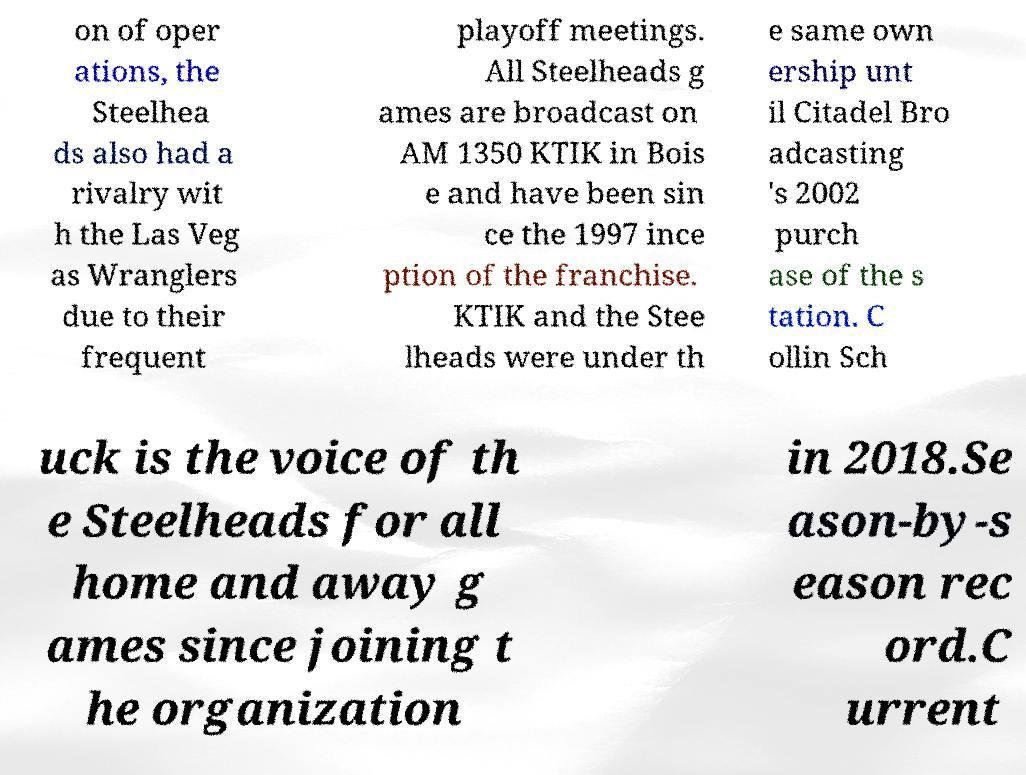Can you accurately transcribe the text from the provided image for me? on of oper ations, the Steelhea ds also had a rivalry wit h the Las Veg as Wranglers due to their frequent playoff meetings. All Steelheads g ames are broadcast on AM 1350 KTIK in Bois e and have been sin ce the 1997 ince ption of the franchise. KTIK and the Stee lheads were under th e same own ership unt il Citadel Bro adcasting 's 2002 purch ase of the s tation. C ollin Sch uck is the voice of th e Steelheads for all home and away g ames since joining t he organization in 2018.Se ason-by-s eason rec ord.C urrent 